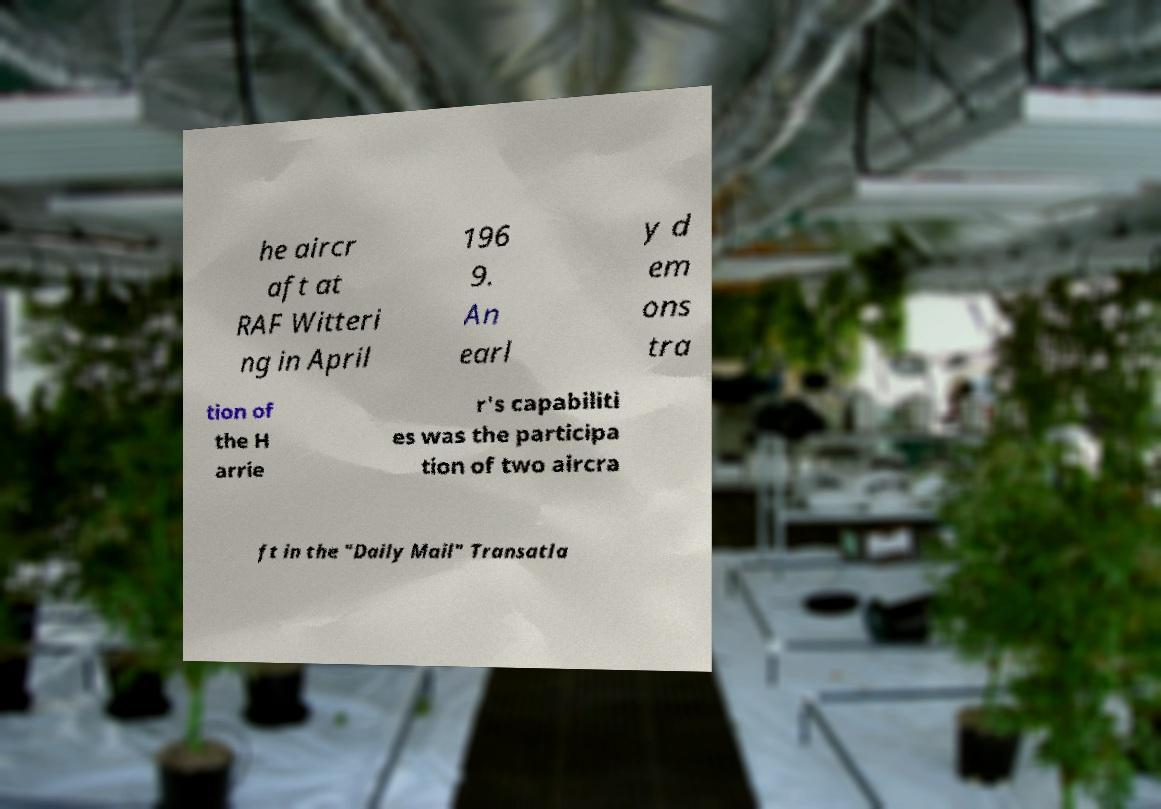Can you accurately transcribe the text from the provided image for me? he aircr aft at RAF Witteri ng in April 196 9. An earl y d em ons tra tion of the H arrie r's capabiliti es was the participa tion of two aircra ft in the "Daily Mail" Transatla 